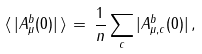Convert formula to latex. <formula><loc_0><loc_0><loc_500><loc_500>\langle \, | A ^ { b } _ { \mu } ( 0 ) | \, \rangle \, = \, \frac { 1 } { n } \sum _ { c } | A ^ { b } _ { \mu , c } ( 0 ) | \, ,</formula> 